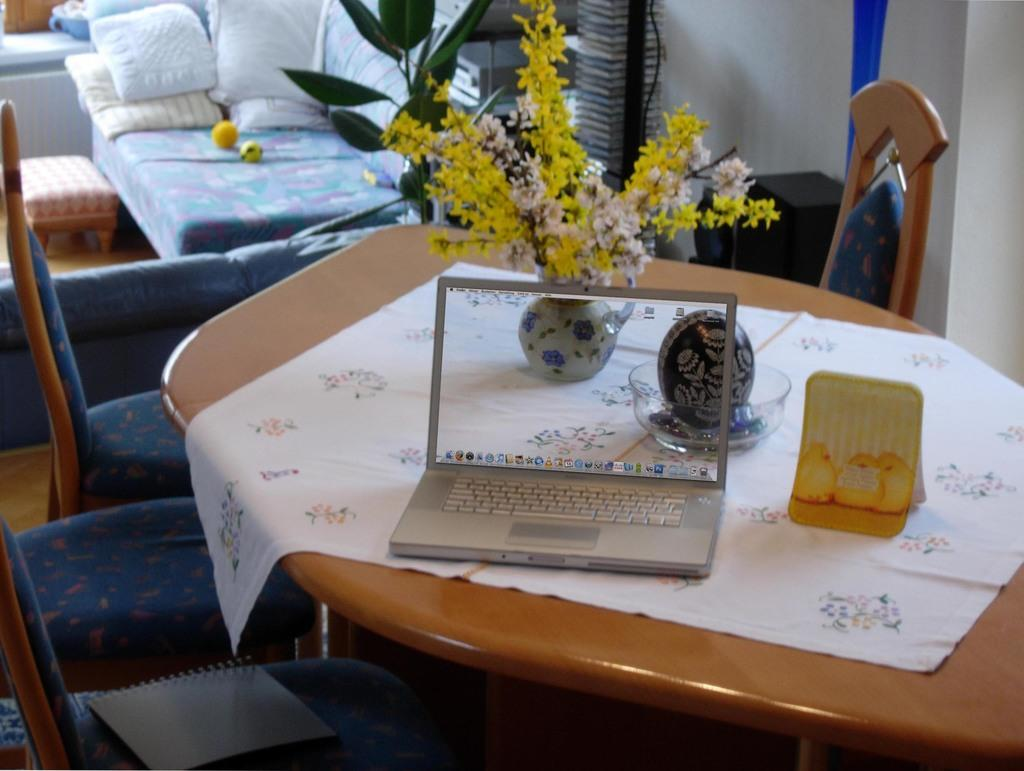What piece of furniture is in the image? There is a table in the image. What electronic device is on the table? A laptop is present on the table. What decorative item is on the table? There is a flower vase on the table. What type of plant is visible on the table? Flowers are visible on the table. What type of dishware is on the table? There is a bowl on the table. What type of table accessory is on the table? There is a table mat on the table. What type of seating is visible in the background of the image? There are chairs in the background of the image. What type of furniture is visible in the background of the image? A sofa is present in the background of the image. What type of cushion is visible in the background of the image? Pillows are visible in the background of the image. How many ants can be seen crawling on the laptop in the image? There are no ants visible on the laptop in the image. What type of wheel is attached to the flower vase in the image? There is no wheel attached to the flower vase in the image. What type of key is used to unlock the laptop in the image? There is no key visible in the image, and the laptop is not locked. 